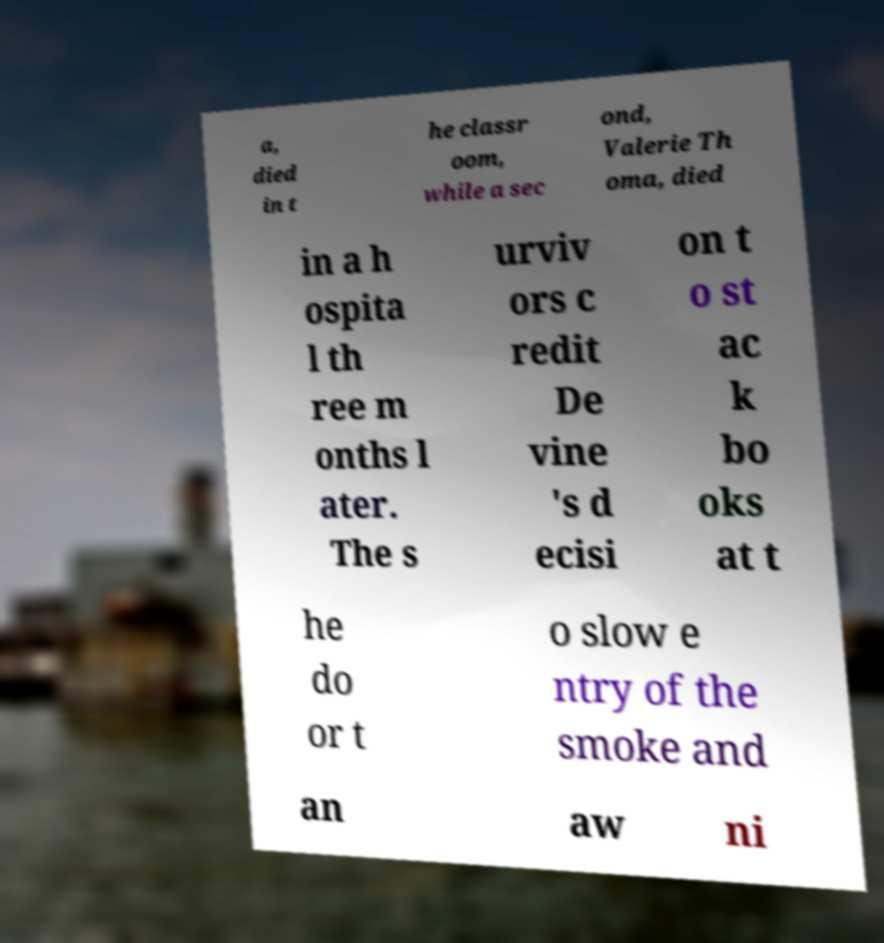Could you assist in decoding the text presented in this image and type it out clearly? a, died in t he classr oom, while a sec ond, Valerie Th oma, died in a h ospita l th ree m onths l ater. The s urviv ors c redit De vine 's d ecisi on t o st ac k bo oks at t he do or t o slow e ntry of the smoke and an aw ni 